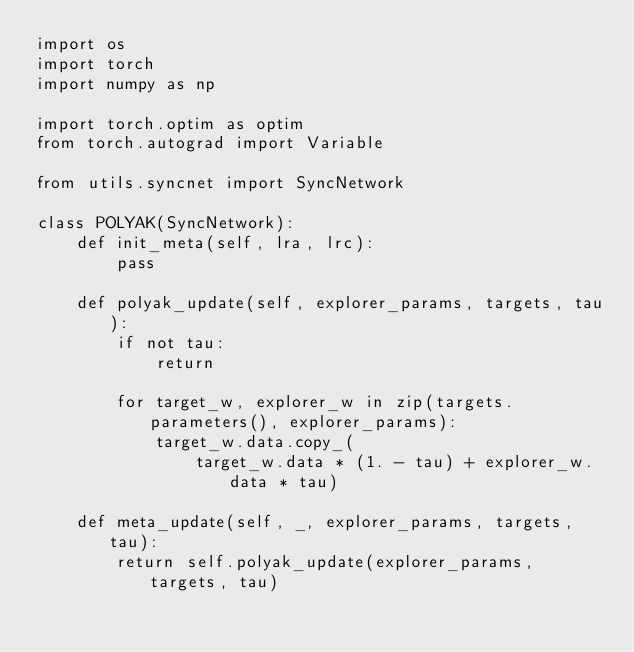<code> <loc_0><loc_0><loc_500><loc_500><_Python_>import os
import torch
import numpy as np

import torch.optim as optim
from torch.autograd import Variable

from utils.syncnet import SyncNetwork

class POLYAK(SyncNetwork):
    def init_meta(self, lra, lrc):
        pass

    def polyak_update(self, explorer_params, targets, tau):
        if not tau:
            return

        for target_w, explorer_w in zip(targets.parameters(), explorer_params):
            target_w.data.copy_(
                target_w.data * (1. - tau) + explorer_w.data * tau)

    def meta_update(self, _, explorer_params, targets, tau):
        return self.polyak_update(explorer_params, targets, tau)
</code> 